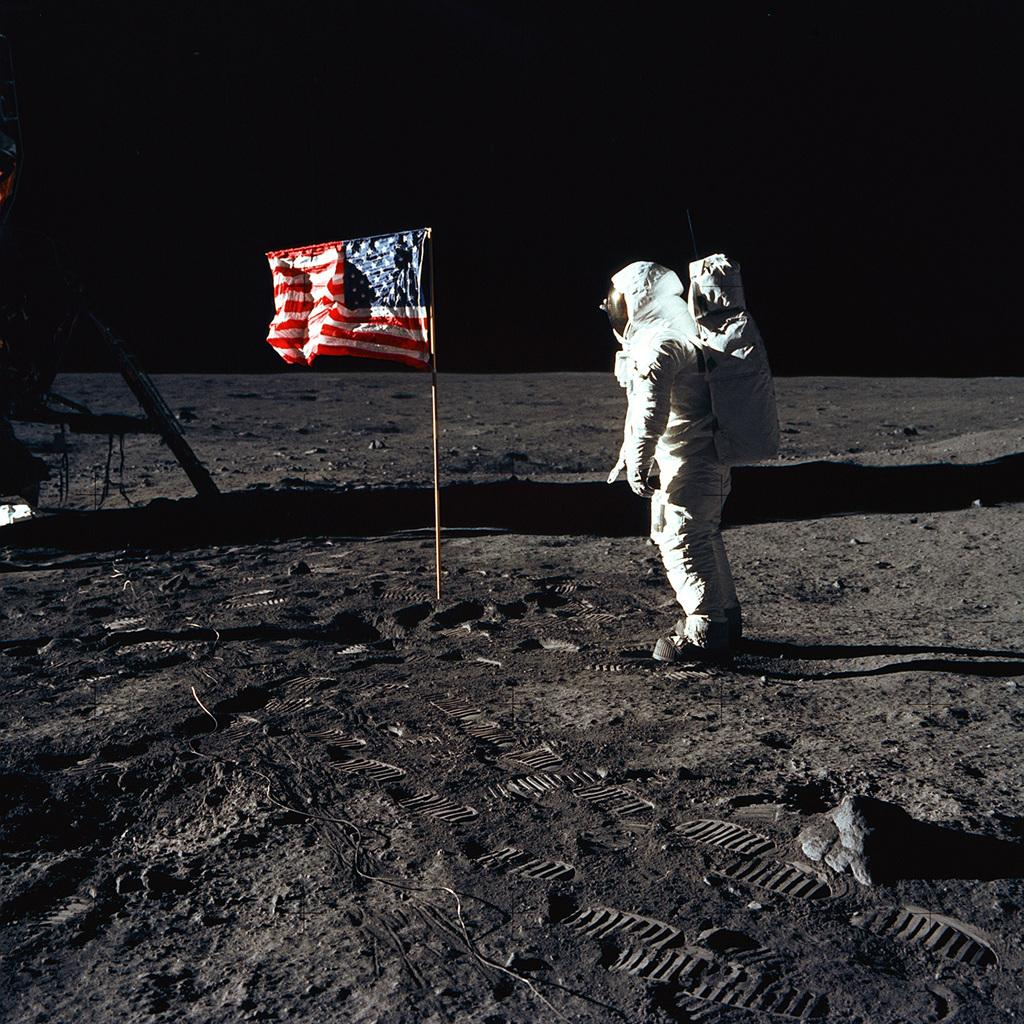What is the person in the image wearing? The person in the image is wearing an astronaut suit. What object can be seen in the image besides the astronaut? There is a machine and a flag attached to a stick on the ground in the image. What is the background of the image? The sky is visible in the background of the image. Can you hear the astronaut whistling in the image? There is no indication of sound in the image, so it cannot be determined if the astronaut is whistling or not. 